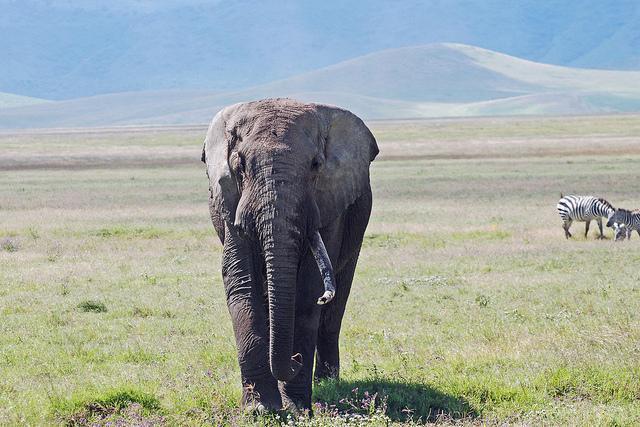What is the elephant missing on its right side?
Pick the correct solution from the four options below to address the question.
Options: Tusk, tail, beard, toe. Tusk. 